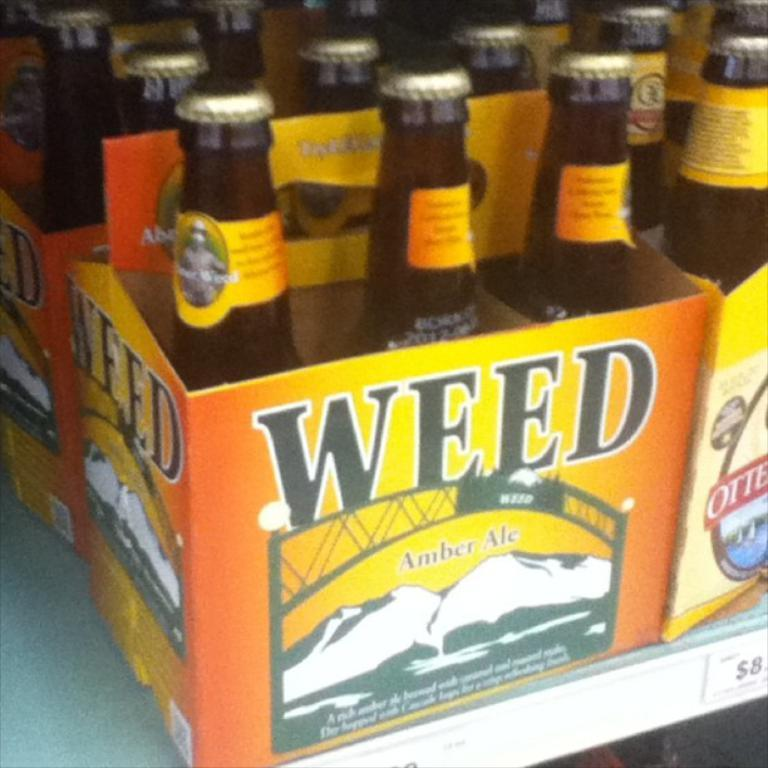<image>
Create a compact narrative representing the image presented. Box of beers with the name WEEd on it. 